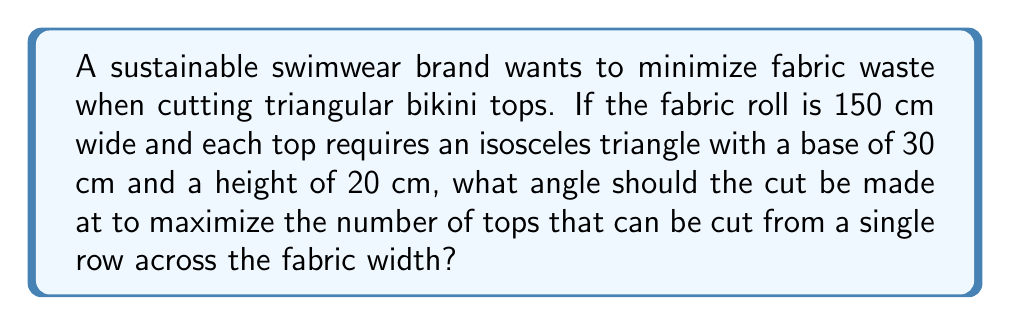Teach me how to tackle this problem. Let's approach this step-by-step:

1) First, we need to find the angle at the apex of the isosceles triangle. We can do this using the tangent function:

   $$\tan(\frac{\theta}{2}) = \frac{15}{20} = 0.75$$

   $$\frac{\theta}{2} = \arctan(0.75) \approx 36.87°$$

   $$\theta \approx 73.74°$$

2) The angle we're looking for is the complement of this angle:

   $$90° - 73.74° = 16.26°$$

3) Now, we need to calculate how many triangles can fit in the 150 cm width when rotated at this angle. The width each triangle takes up is:

   $$30 \cdot \cos(16.26°) \approx 28.78 \text{ cm}$$

4) The number of triangles that can fit is:

   $$\frac{150}{28.78} \approx 5.21$$

5) Rounding down, we get 5 triangles.

6) To verify this is the most efficient angle, we can check angles slightly above and below:
   - At 15°: $30 \cdot \cos(15°) \approx 28.98 \text{ cm}$, still fits 5 triangles
   - At 17°: $30 \cdot \cos(17°) \approx 28.68 \text{ cm}$, still fits 5 triangles
   - At 18°: $30 \cdot \cos(18°) \approx 28.53 \text{ cm}$, fits 5.25 triangles, but we can't cut partial triangles

Therefore, any angle between approximately 16.26° and 18° will yield the maximum number of triangles (5) from a single row.
Answer: 16.26° to 18° 